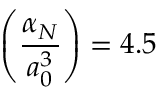Convert formula to latex. <formula><loc_0><loc_0><loc_500><loc_500>\left ( \frac { \alpha _ { N } } { a _ { 0 } ^ { 3 } } \right ) = 4 . 5</formula> 